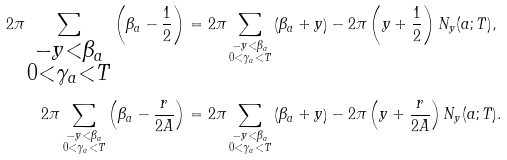Convert formula to latex. <formula><loc_0><loc_0><loc_500><loc_500>2 \pi \sum _ { \substack { - y < \beta _ { a } \\ 0 < \gamma _ { a } < T } } \left ( \beta _ { a } - \frac { 1 } { 2 } \right ) & = 2 \pi \sum _ { \substack { - y < \beta _ { a } \\ 0 < \gamma _ { a } < T } } \left ( \beta _ { a } + y \right ) - 2 \pi \left ( y + \frac { 1 } { 2 } \right ) N _ { y } ( a ; T ) , \\ 2 \pi \sum _ { \substack { - y < \beta _ { a } \\ 0 < \gamma _ { a } < T } } \left ( \beta _ { a } - \frac { r } { 2 A } \right ) & = 2 \pi \sum _ { \substack { - y < \beta _ { a } \\ 0 < \gamma _ { a } < T } } \left ( \beta _ { a } + y \right ) - 2 \pi \left ( y + \frac { r } { 2 A } \right ) N _ { y } ( a ; T ) .</formula> 